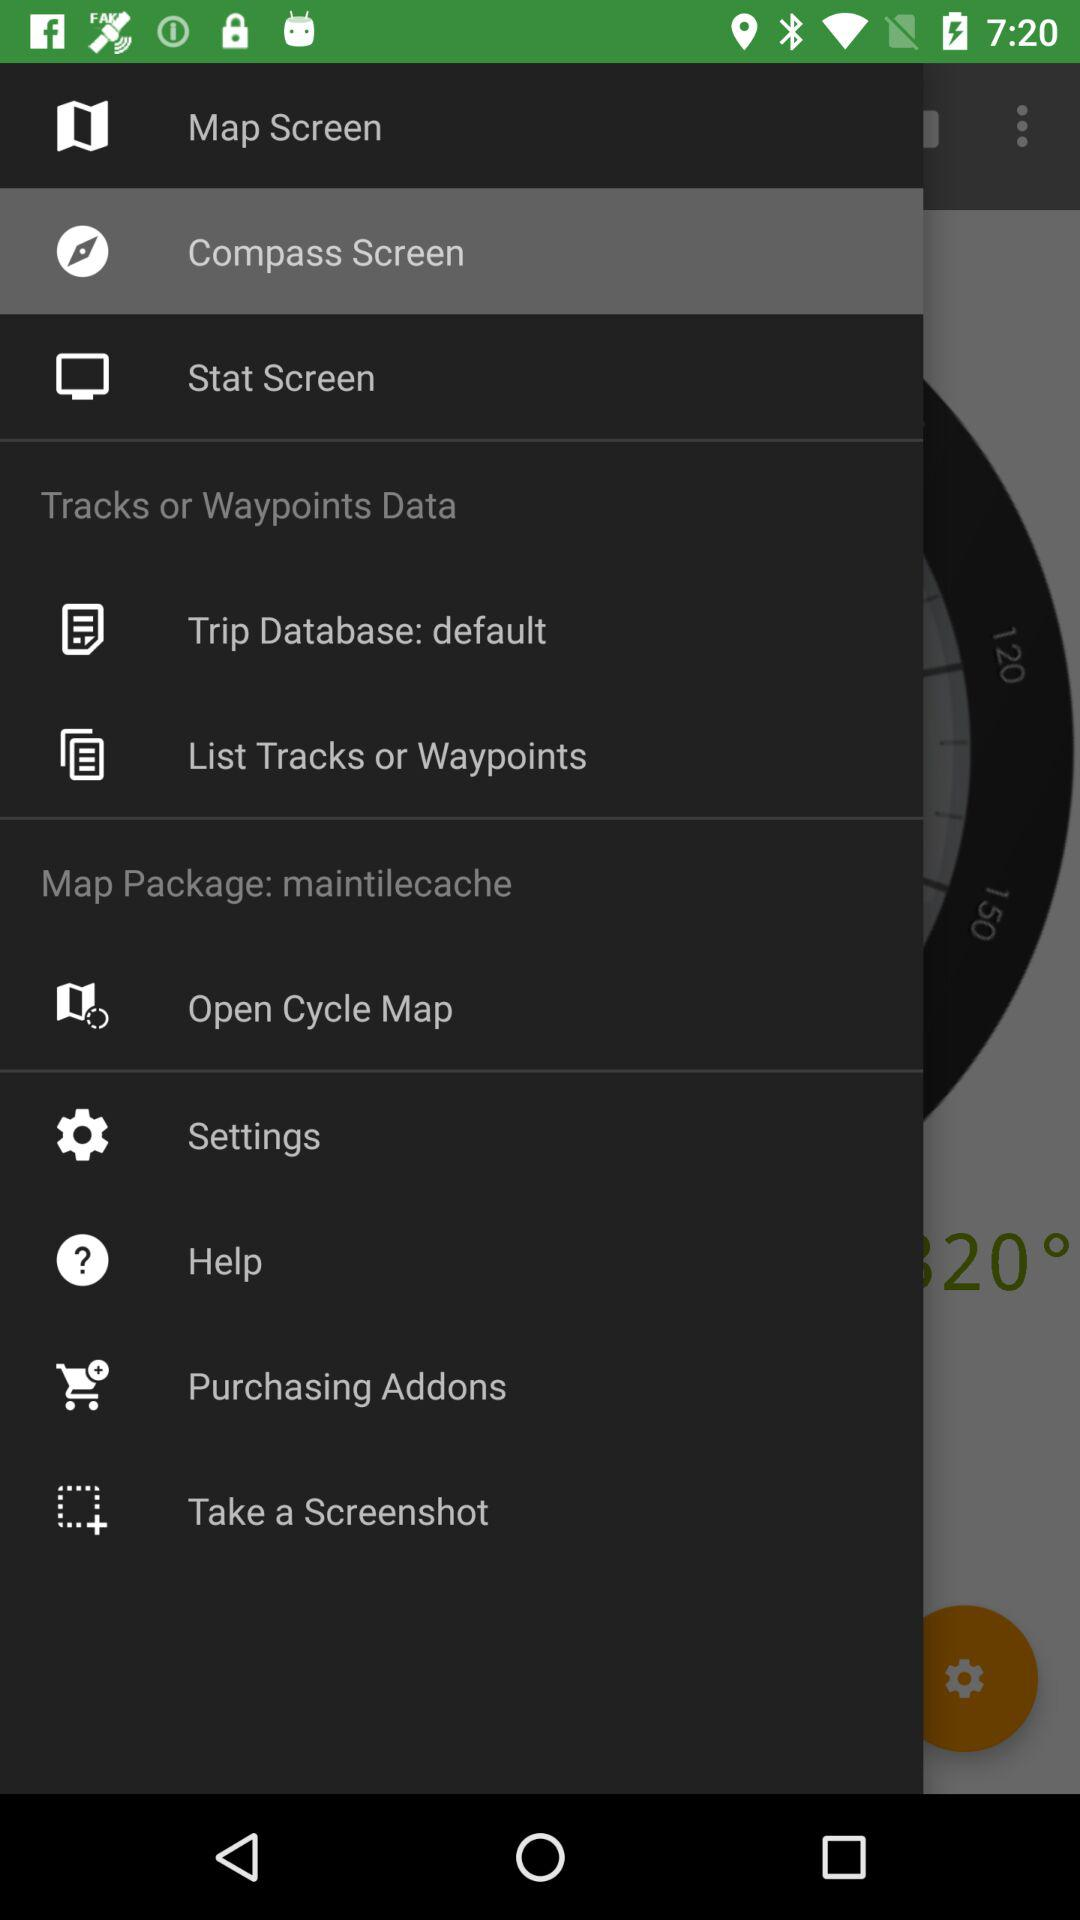How many map sources are displayed?
Answer the question using a single word or phrase. 4 